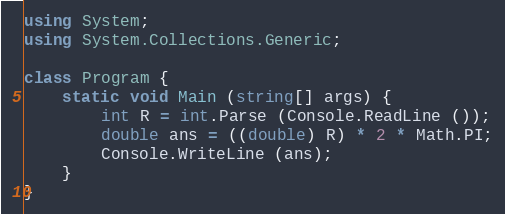Convert code to text. <code><loc_0><loc_0><loc_500><loc_500><_C#_>using System;
using System.Collections.Generic;

class Program {
    static void Main (string[] args) {
        int R = int.Parse (Console.ReadLine ());
        double ans = ((double) R) * 2 * Math.PI;
        Console.WriteLine (ans);
    }
}</code> 